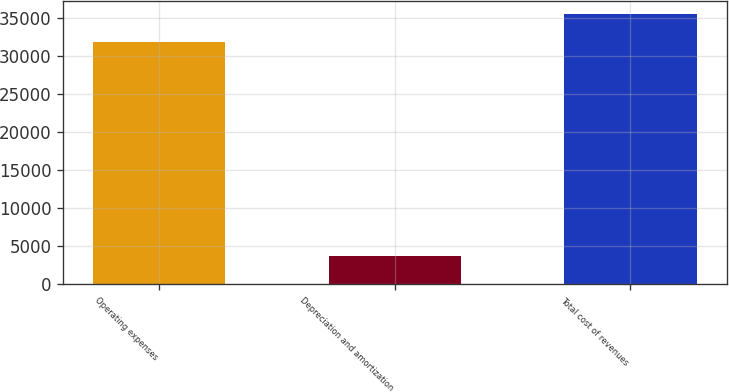Convert chart to OTSL. <chart><loc_0><loc_0><loc_500><loc_500><bar_chart><fcel>Operating expenses<fcel>Depreciation and amortization<fcel>Total cost of revenues<nl><fcel>31790<fcel>3683<fcel>35473<nl></chart> 